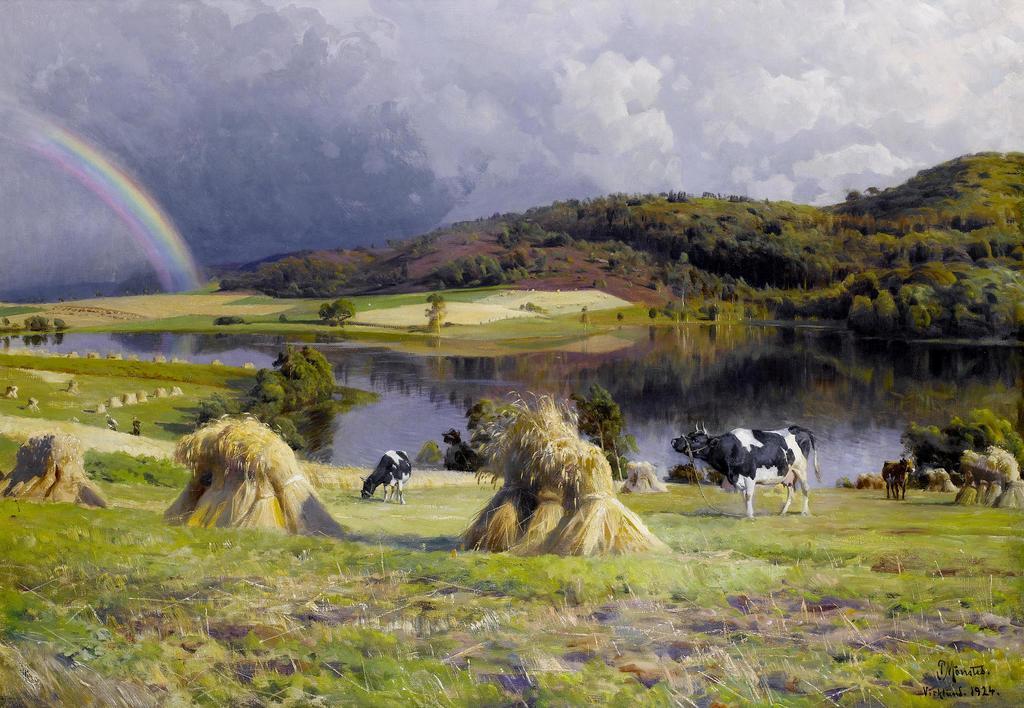Can you describe this image briefly? There are some cows on the grassy land as we can see at the bottom of this image. There is a pond in the middle of this image and there are some trees and a mountain in the background. There is a sky at the top of this image, as we can see there is a rainbow at the top left side of this image. 